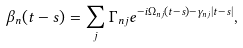<formula> <loc_0><loc_0><loc_500><loc_500>\beta _ { n } ( t - s ) = \sum _ { j } \Gamma _ { n j } e ^ { - i \Omega _ { n j } ( t - s ) - \gamma _ { n j } | t - s | } ,</formula> 